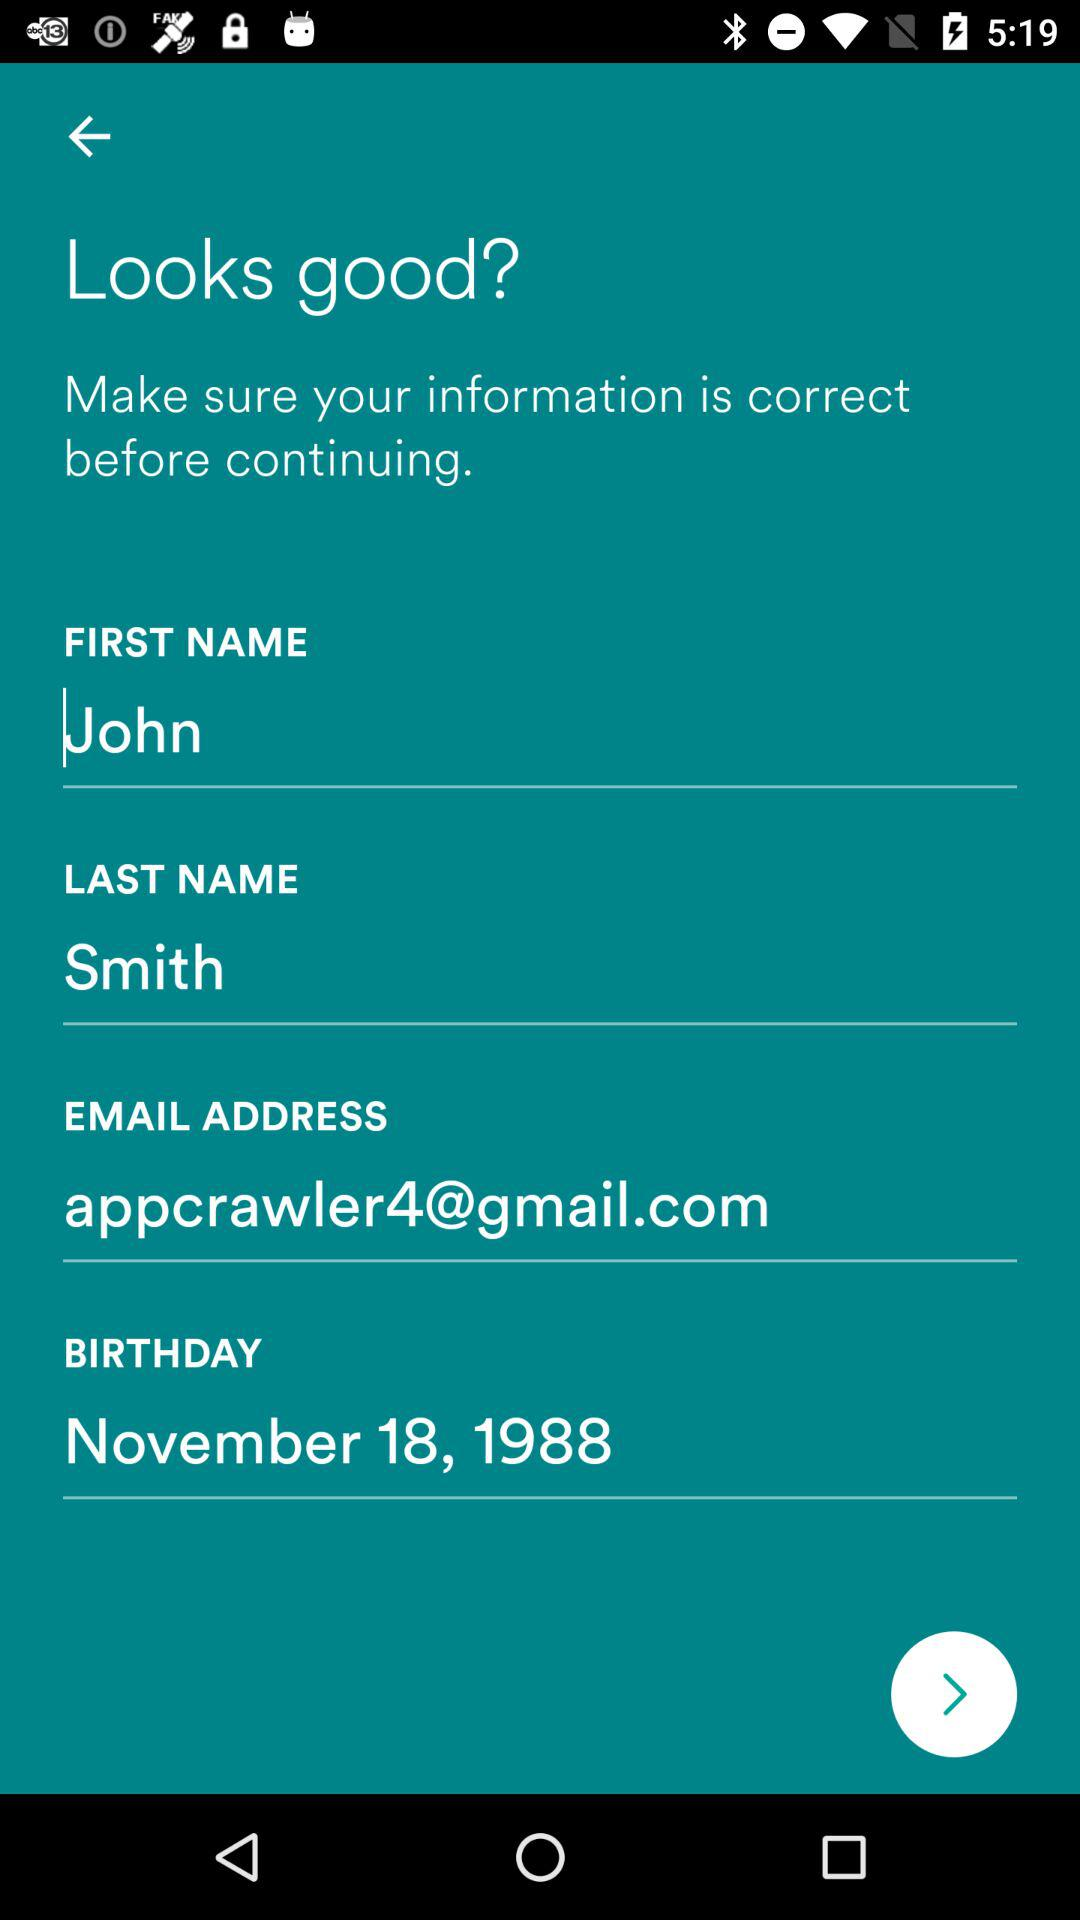What is the last name? The last name is Smith. 